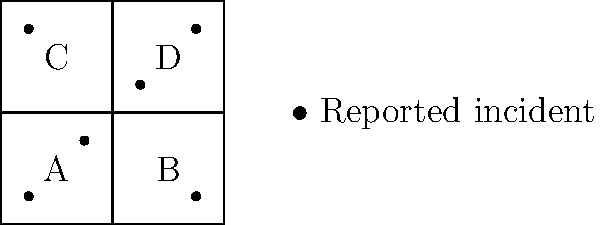A community monitoring group has divided their neighborhood into four equal-sized square areas (A, B, C, and D) as shown in the map. Each area is 2 km × 2 km. The dots represent reported incidents of police misconduct. If the density of reported incidents is defined as the number of incidents per square kilometer, what is the difference between the highest and lowest incident densities among the four areas? To solve this problem, we need to follow these steps:

1. Calculate the area of each neighborhood:
   Area = 2 km × 2 km = 4 km²

2. Count the number of incidents in each neighborhood:
   A: 2 incidents
   B: 1 incident
   C: 1 incident
   D: 2 incidents

3. Calculate the density for each neighborhood:
   Density = Number of incidents ÷ Area

   A: $\frac{2}{4} = 0.5$ incidents/km²
   B: $\frac{1}{4} = 0.25$ incidents/km²
   C: $\frac{1}{4} = 0.25$ incidents/km²
   D: $\frac{2}{4} = 0.5$ incidents/km²

4. Identify the highest and lowest densities:
   Highest: 0.5 incidents/km² (A and D)
   Lowest: 0.25 incidents/km² (B and C)

5. Calculate the difference between the highest and lowest densities:
   Difference = Highest density - Lowest density
   $$ 0.5 - 0.25 = 0.25 \text{ incidents/km²} $$

Therefore, the difference between the highest and lowest incident densities is 0.25 incidents/km².
Answer: 0.25 incidents/km² 